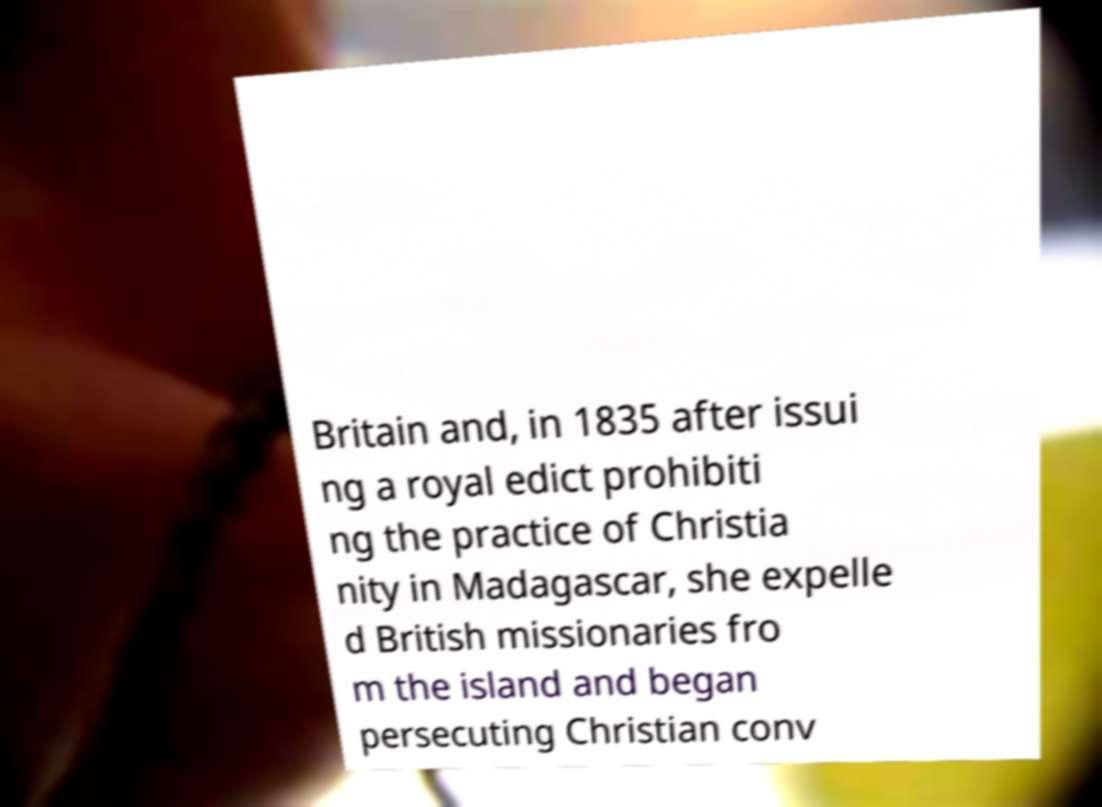I need the written content from this picture converted into text. Can you do that? Britain and, in 1835 after issui ng a royal edict prohibiti ng the practice of Christia nity in Madagascar, she expelle d British missionaries fro m the island and began persecuting Christian conv 